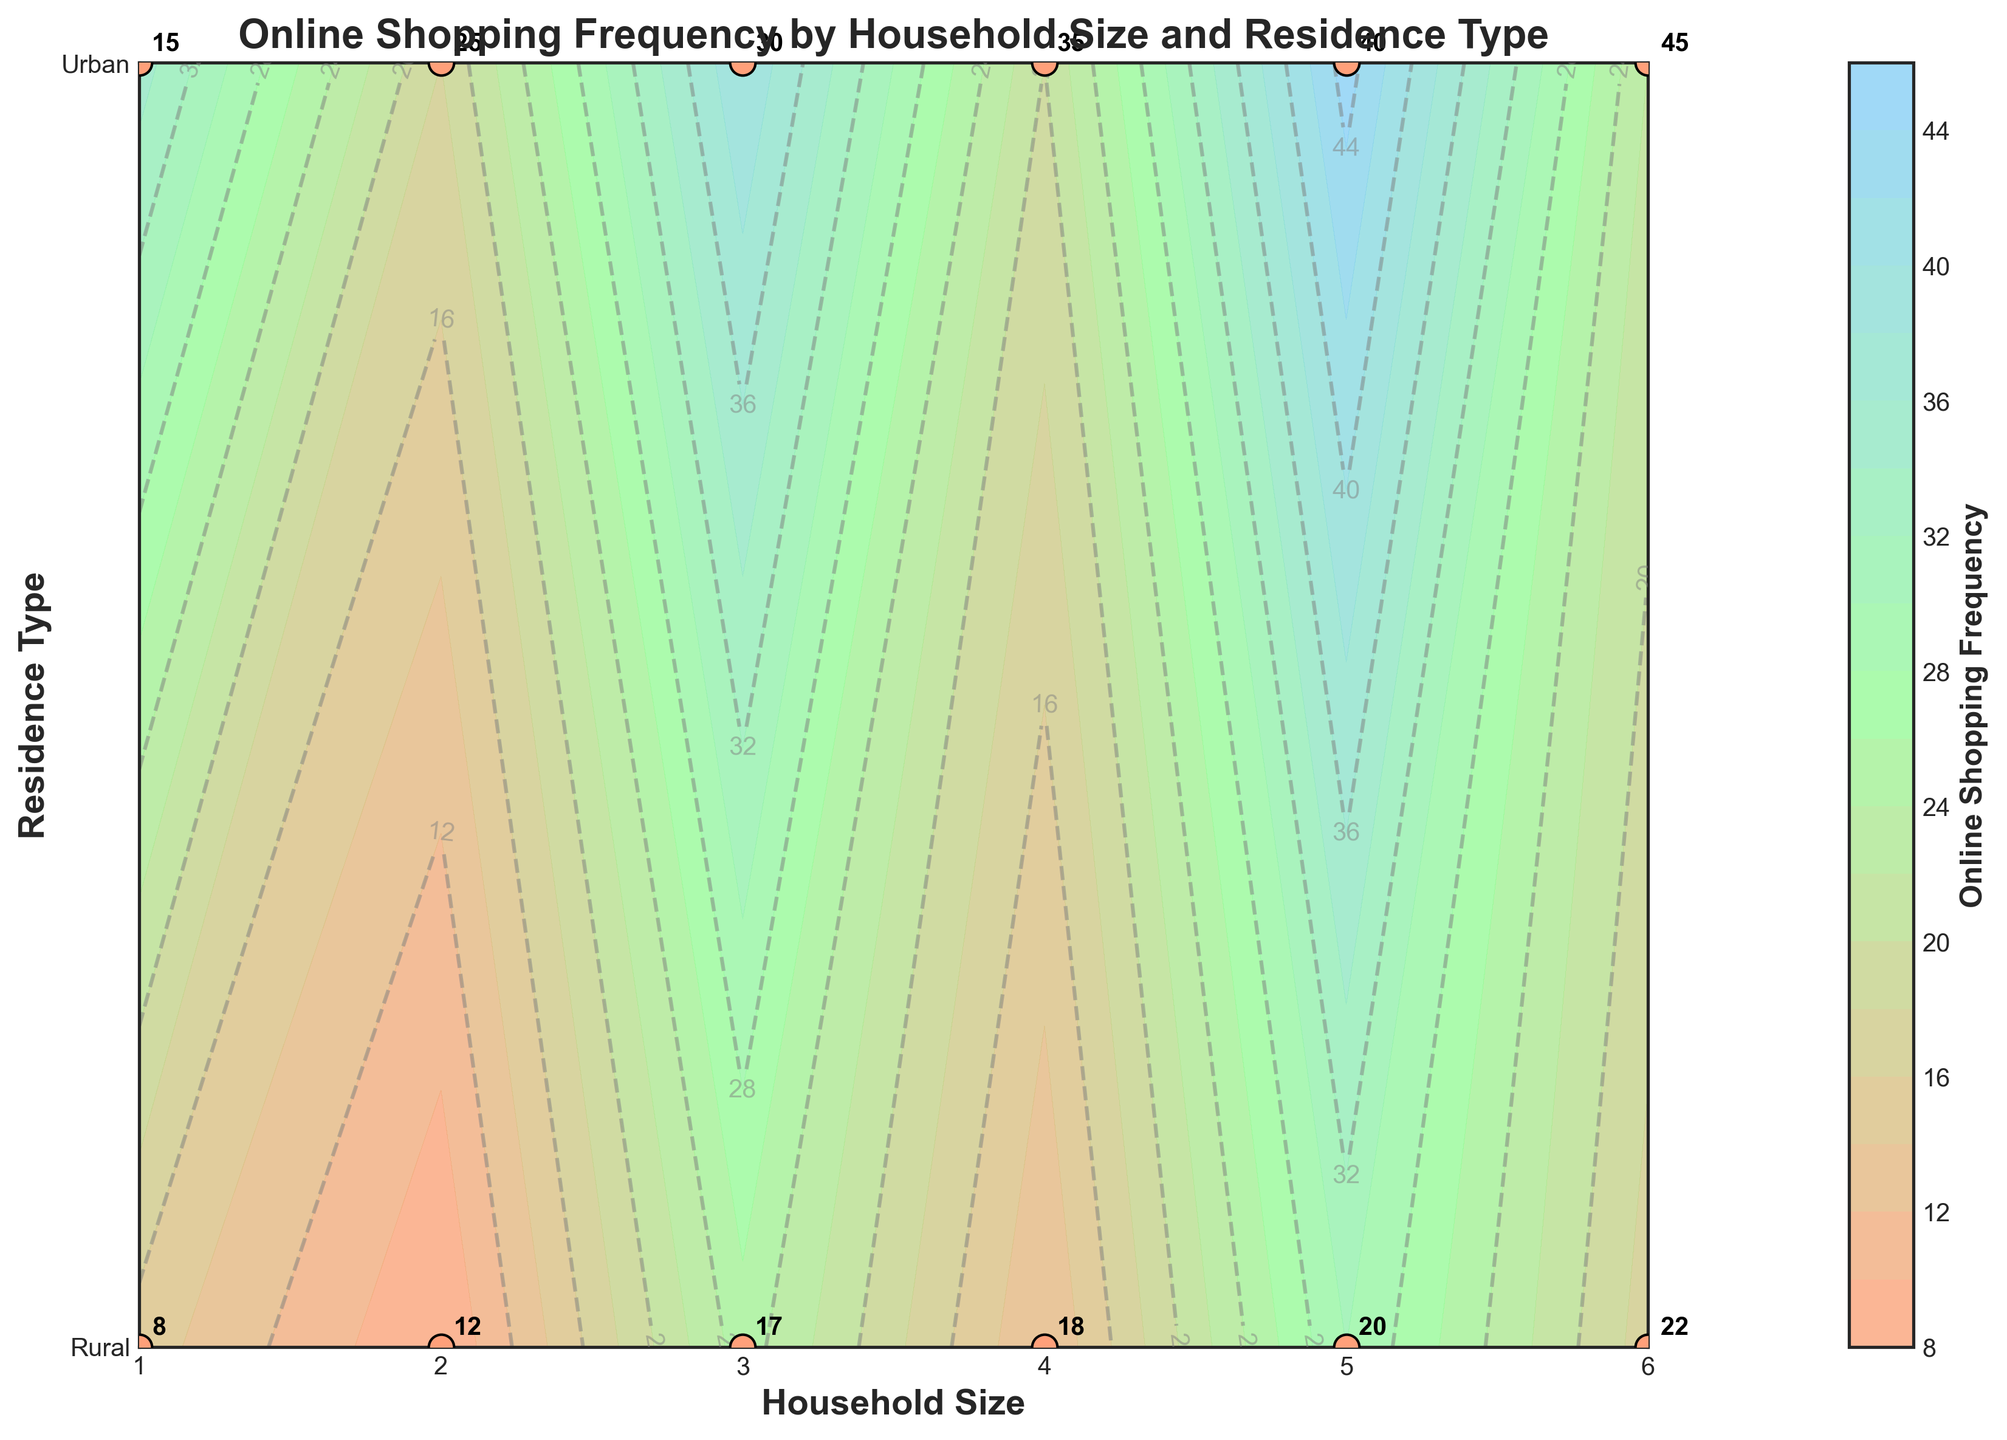What is the title of the plot? The title is usually found at the top of the plot and summarizes the main topic it represents. In this case, it describes the relationship between online shopping frequency, household size, and residence type.
Answer: Online Shopping Frequency by Household Size and Residence Type What do the axes represent? The x-axis (horizontal) represents household size, ranging from 1 to 6. The y-axis (vertical) represents residence type, which includes 'Urban' and 'Rural'.
Answer: Household size and Residence type How many data points are there in total? Each household size has two data points, one for Urban and one for Rural, resulting in a total of 6 household sizes multiplied by 2 residence types.
Answer: 12 Which residence type has a higher online shopping frequency for a household size of 4? Locate household size 4 on the x-axis and compare the frequencies for both Urban and Rural on the y-axis. The Urban frequency is higher.
Answer: Urban What is the color bar representing? The color bar provides a visual representation of online shopping frequency. The colors range from lighter to darker shades to indicate the frequency's intensity.
Answer: Online shopping frequency What is the online shopping frequency for a household size of 2 in a Rural area? Find the point corresponding to household size 2 and Rural residence type; the plot label indicates the frequency directly.
Answer: 12 Compare the online shopping frequency between household sizes 1 and 6 for Urban residences. Locate the frequencies for Urban residences at household sizes 1 and 6 on the x-axis and compare the two values. House size 1 has a frequency of 15, and house size 6 has 45.
Answer: 15 and 45 What is the average online shopping frequency for all Rural residences? Sum the online shopping frequencies for Rural areas (8+12+17+18+20+22 = 97) and divide by the number of data points (6).
Answer: 16.17 Which household size has the highest online shopping frequency for a Rural residence? Compare the frequencies for Rural residences at all household sizes and identify the highest.
Answer: 6 How does the online shopping frequency trend change as household size increases for Urban residences? Observe how the online shopping frequency changes along the x-axis from household size 1 to 6 for Urban residences. The frequency consistently increases.
Answer: It increases 